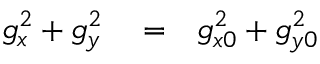Convert formula to latex. <formula><loc_0><loc_0><loc_500><loc_500>\begin{array} { r l r } { g _ { x } ^ { 2 } + g _ { y } ^ { 2 } } & = } & { g _ { x 0 } ^ { 2 } + g _ { y 0 } ^ { 2 } } \end{array}</formula> 